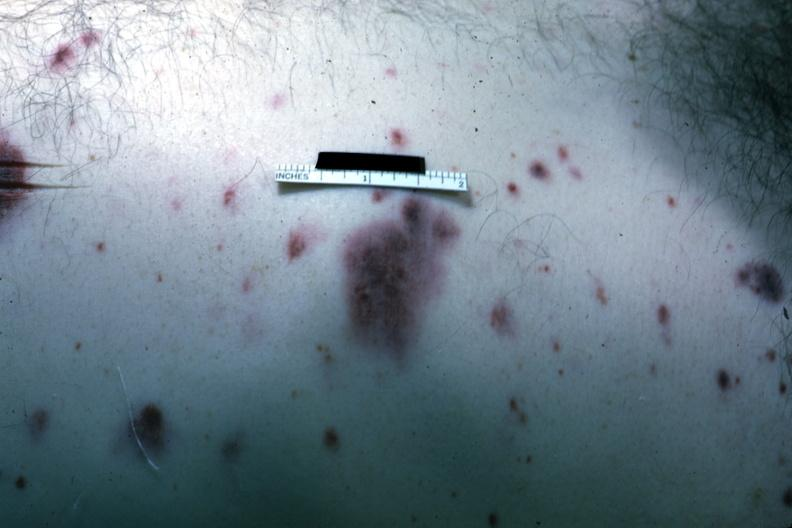what does this image show?
Answer the question using a single word or phrase. Rather close-up view of typical skin hemorrhages case of acute myelogenous leukemia with terminal candida infection 